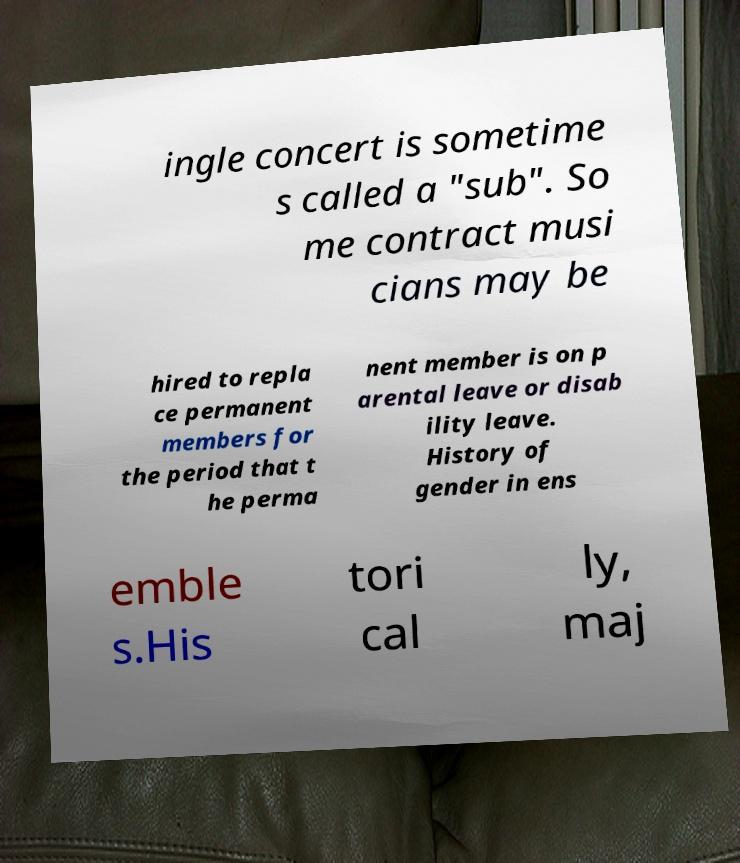Could you assist in decoding the text presented in this image and type it out clearly? ingle concert is sometime s called a "sub". So me contract musi cians may be hired to repla ce permanent members for the period that t he perma nent member is on p arental leave or disab ility leave. History of gender in ens emble s.His tori cal ly, maj 